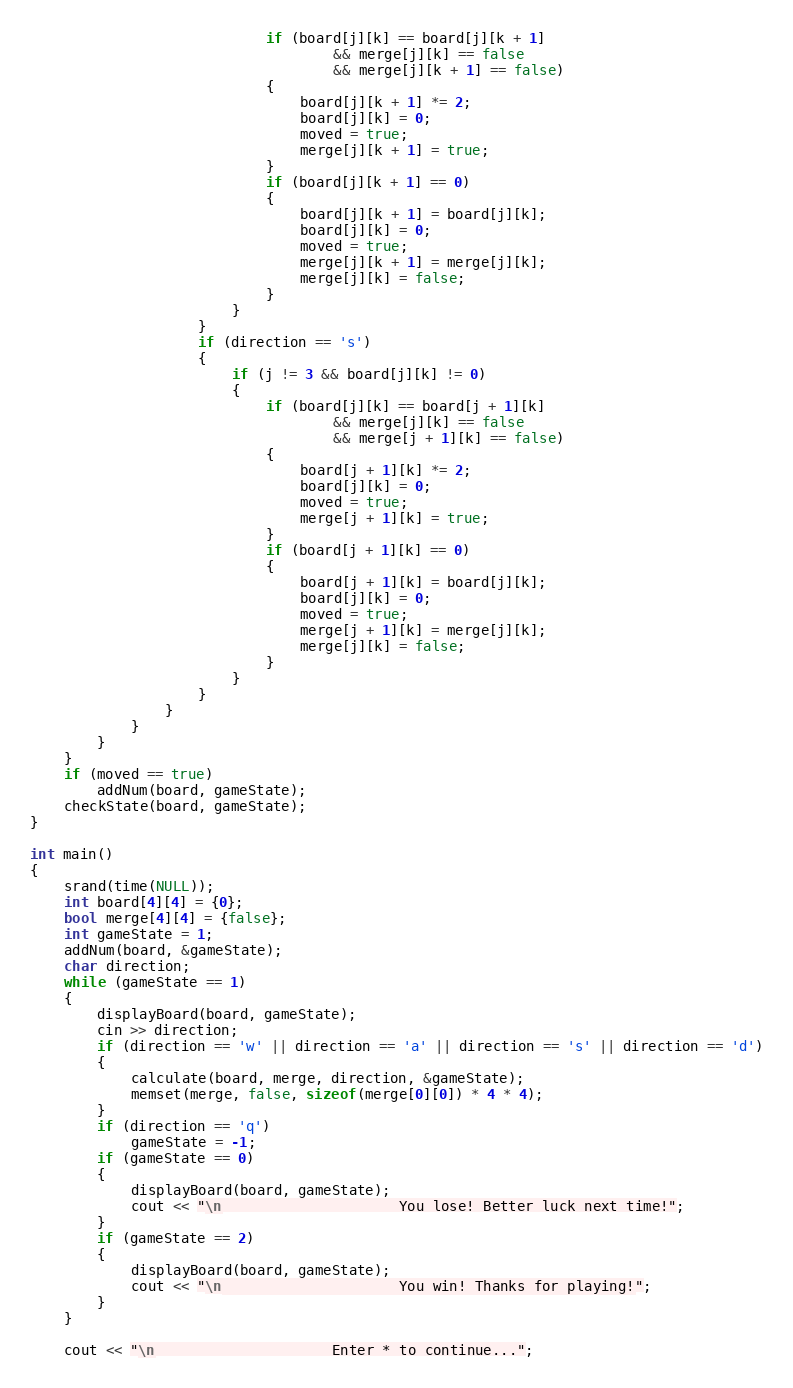Convert code to text. <code><loc_0><loc_0><loc_500><loc_500><_C++_>                            if (board[j][k] == board[j][k + 1]
                                    && merge[j][k] == false
                                    && merge[j][k + 1] == false)
                            {
                                board[j][k + 1] *= 2;
                                board[j][k] = 0;
                                moved = true;
                                merge[j][k + 1] = true;
                            }
                            if (board[j][k + 1] == 0)
                            {
                                board[j][k + 1] = board[j][k];
                                board[j][k] = 0;
                                moved = true;
                                merge[j][k + 1] = merge[j][k];
                                merge[j][k] = false;
                            }
                        }
                    }
                    if (direction == 's')
                    {
                        if (j != 3 && board[j][k] != 0)
                        {
                            if (board[j][k] == board[j + 1][k]
                                    && merge[j][k] == false
                                    && merge[j + 1][k] == false)
                            {
                                board[j + 1][k] *= 2;
                                board[j][k] = 0;
                                moved = true;
                                merge[j + 1][k] = true;
                            }
                            if (board[j + 1][k] == 0)
                            {
                                board[j + 1][k] = board[j][k];
                                board[j][k] = 0;
                                moved = true;
                                merge[j + 1][k] = merge[j][k];
                                merge[j][k] = false;
                            }
                        }
                    }
                }
            }
        }
    }
    if (moved == true)
        addNum(board, gameState);
    checkState(board, gameState);
}

int main()
{
    srand(time(NULL));
    int board[4][4] = {0};
    bool merge[4][4] = {false};
    int gameState = 1;
    addNum(board, &gameState);
    char direction;
    while (gameState == 1)
    {
        displayBoard(board, gameState);
        cin >> direction;
        if (direction == 'w' || direction == 'a' || direction == 's' || direction == 'd')
        {
            calculate(board, merge, direction, &gameState);
            memset(merge, false, sizeof(merge[0][0]) * 4 * 4);
        }
        if (direction == 'q')
            gameState = -1;
        if (gameState == 0)
        {
            displayBoard(board, gameState);
            cout << "\n                     You lose! Better luck next time!";
        }
        if (gameState == 2)
        {
            displayBoard(board, gameState);
            cout << "\n                     You win! Thanks for playing!";
        }
    }

    cout << "\n                     Enter * to continue...";</code> 